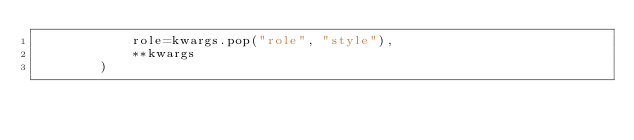<code> <loc_0><loc_0><loc_500><loc_500><_Python_>            role=kwargs.pop("role", "style"),
            **kwargs
        )
</code> 